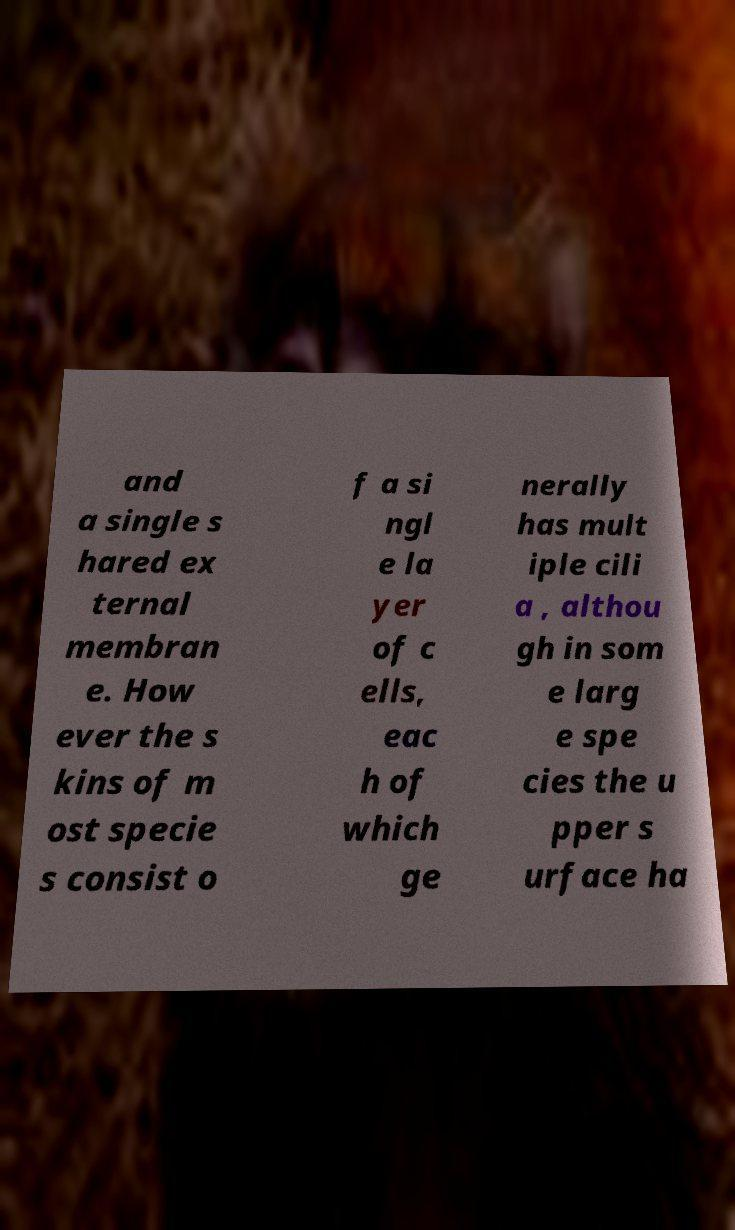Please read and relay the text visible in this image. What does it say? and a single s hared ex ternal membran e. How ever the s kins of m ost specie s consist o f a si ngl e la yer of c ells, eac h of which ge nerally has mult iple cili a , althou gh in som e larg e spe cies the u pper s urface ha 